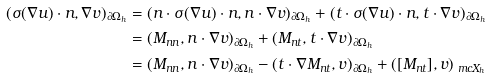<formula> <loc_0><loc_0><loc_500><loc_500>( \sigma ( \nabla u ) \cdot n , \nabla v ) _ { \partial \Omega _ { h } } & = ( n \cdot \sigma ( \nabla u ) \cdot n , n \cdot \nabla v ) _ { \partial \Omega _ { h } } + ( t \cdot \sigma ( \nabla u ) \cdot n , t \cdot \nabla v ) _ { \partial \Omega _ { h } } \\ & = ( M _ { n n } , n \cdot \nabla v ) _ { \partial \Omega _ { h } } + ( M _ { n t } , t \cdot \nabla v ) _ { \partial \Omega _ { h } } \\ & = ( M _ { n n } , n \cdot \nabla v ) _ { \partial \Omega _ { h } } - ( t \cdot \nabla M _ { n t } , v ) _ { \partial \Omega _ { h } } + ( [ M _ { n t } ] , v ) _ { \ m c X _ { h } }</formula> 